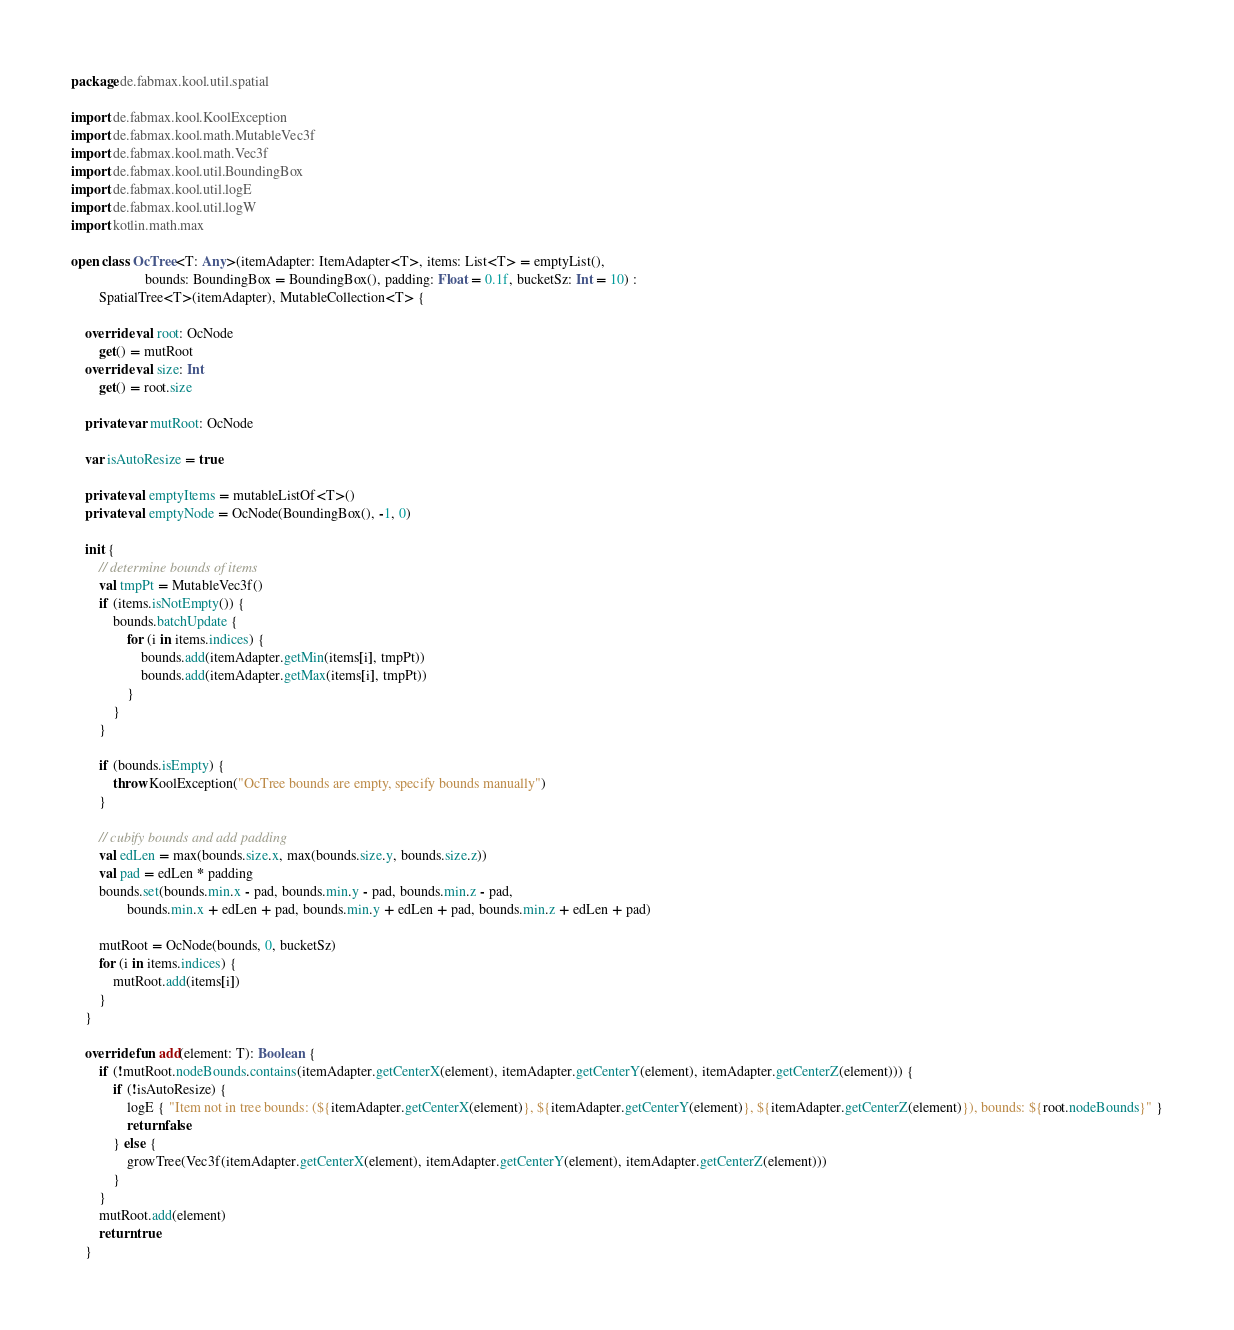<code> <loc_0><loc_0><loc_500><loc_500><_Kotlin_>package de.fabmax.kool.util.spatial

import de.fabmax.kool.KoolException
import de.fabmax.kool.math.MutableVec3f
import de.fabmax.kool.math.Vec3f
import de.fabmax.kool.util.BoundingBox
import de.fabmax.kool.util.logE
import de.fabmax.kool.util.logW
import kotlin.math.max

open class OcTree<T: Any>(itemAdapter: ItemAdapter<T>, items: List<T> = emptyList(),
                     bounds: BoundingBox = BoundingBox(), padding: Float = 0.1f, bucketSz: Int = 10) :
        SpatialTree<T>(itemAdapter), MutableCollection<T> {

    override val root: OcNode
        get() = mutRoot
    override val size: Int
        get() = root.size

    private var mutRoot: OcNode

    var isAutoResize = true

    private val emptyItems = mutableListOf<T>()
    private val emptyNode = OcNode(BoundingBox(), -1, 0)

    init {
        // determine bounds of items
        val tmpPt = MutableVec3f()
        if (items.isNotEmpty()) {
            bounds.batchUpdate {
                for (i in items.indices) {
                    bounds.add(itemAdapter.getMin(items[i], tmpPt))
                    bounds.add(itemAdapter.getMax(items[i], tmpPt))
                }
            }
        }

        if (bounds.isEmpty) {
            throw KoolException("OcTree bounds are empty, specify bounds manually")
        }

        // cubify bounds and add padding
        val edLen = max(bounds.size.x, max(bounds.size.y, bounds.size.z))
        val pad = edLen * padding
        bounds.set(bounds.min.x - pad, bounds.min.y - pad, bounds.min.z - pad,
                bounds.min.x + edLen + pad, bounds.min.y + edLen + pad, bounds.min.z + edLen + pad)

        mutRoot = OcNode(bounds, 0, bucketSz)
        for (i in items.indices) {
            mutRoot.add(items[i])
        }
    }

    override fun add(element: T): Boolean {
        if (!mutRoot.nodeBounds.contains(itemAdapter.getCenterX(element), itemAdapter.getCenterY(element), itemAdapter.getCenterZ(element))) {
            if (!isAutoResize) {
                logE { "Item not in tree bounds: (${itemAdapter.getCenterX(element)}, ${itemAdapter.getCenterY(element)}, ${itemAdapter.getCenterZ(element)}), bounds: ${root.nodeBounds}" }
                return false
            } else {
                growTree(Vec3f(itemAdapter.getCenterX(element), itemAdapter.getCenterY(element), itemAdapter.getCenterZ(element)))
            }
        }
        mutRoot.add(element)
        return true
    }
</code> 